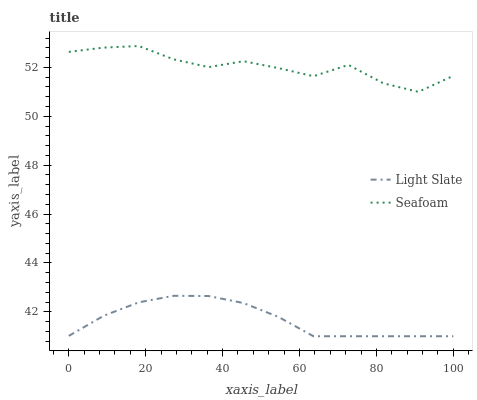Does Light Slate have the minimum area under the curve?
Answer yes or no. Yes. Does Seafoam have the maximum area under the curve?
Answer yes or no. Yes. Does Seafoam have the minimum area under the curve?
Answer yes or no. No. Is Light Slate the smoothest?
Answer yes or no. Yes. Is Seafoam the roughest?
Answer yes or no. Yes. Is Seafoam the smoothest?
Answer yes or no. No. Does Light Slate have the lowest value?
Answer yes or no. Yes. Does Seafoam have the lowest value?
Answer yes or no. No. Does Seafoam have the highest value?
Answer yes or no. Yes. Is Light Slate less than Seafoam?
Answer yes or no. Yes. Is Seafoam greater than Light Slate?
Answer yes or no. Yes. Does Light Slate intersect Seafoam?
Answer yes or no. No. 